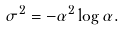Convert formula to latex. <formula><loc_0><loc_0><loc_500><loc_500>\sigma ^ { 2 } = - \alpha ^ { 2 } \log \alpha .</formula> 